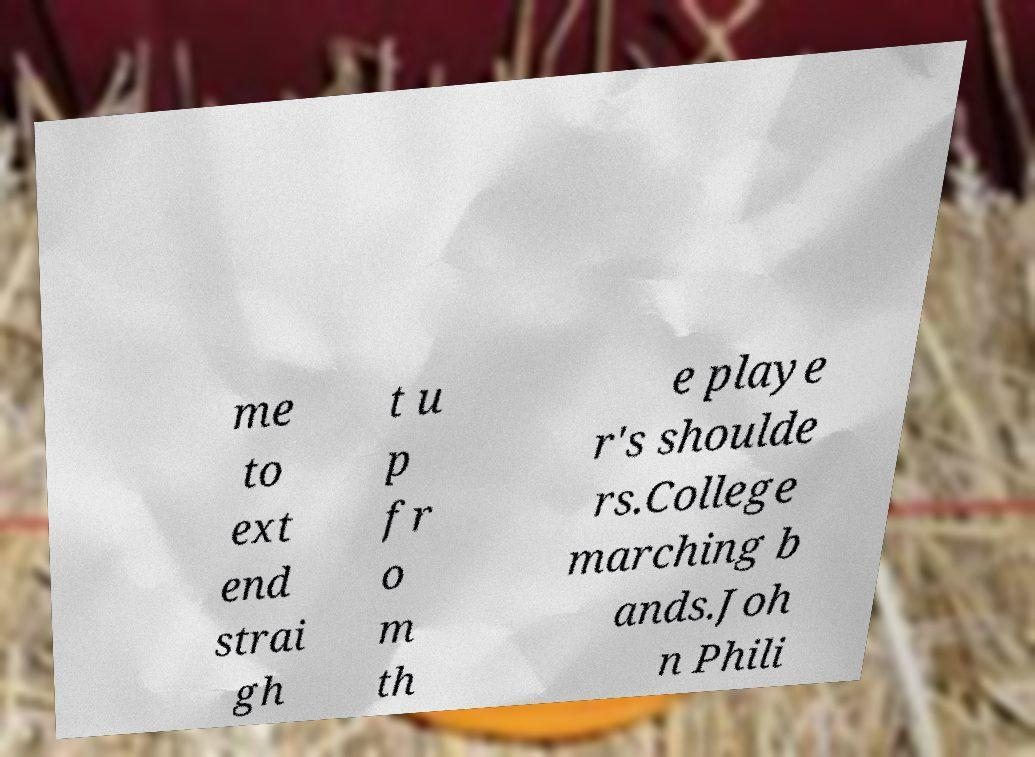For documentation purposes, I need the text within this image transcribed. Could you provide that? me to ext end strai gh t u p fr o m th e playe r's shoulde rs.College marching b ands.Joh n Phili 